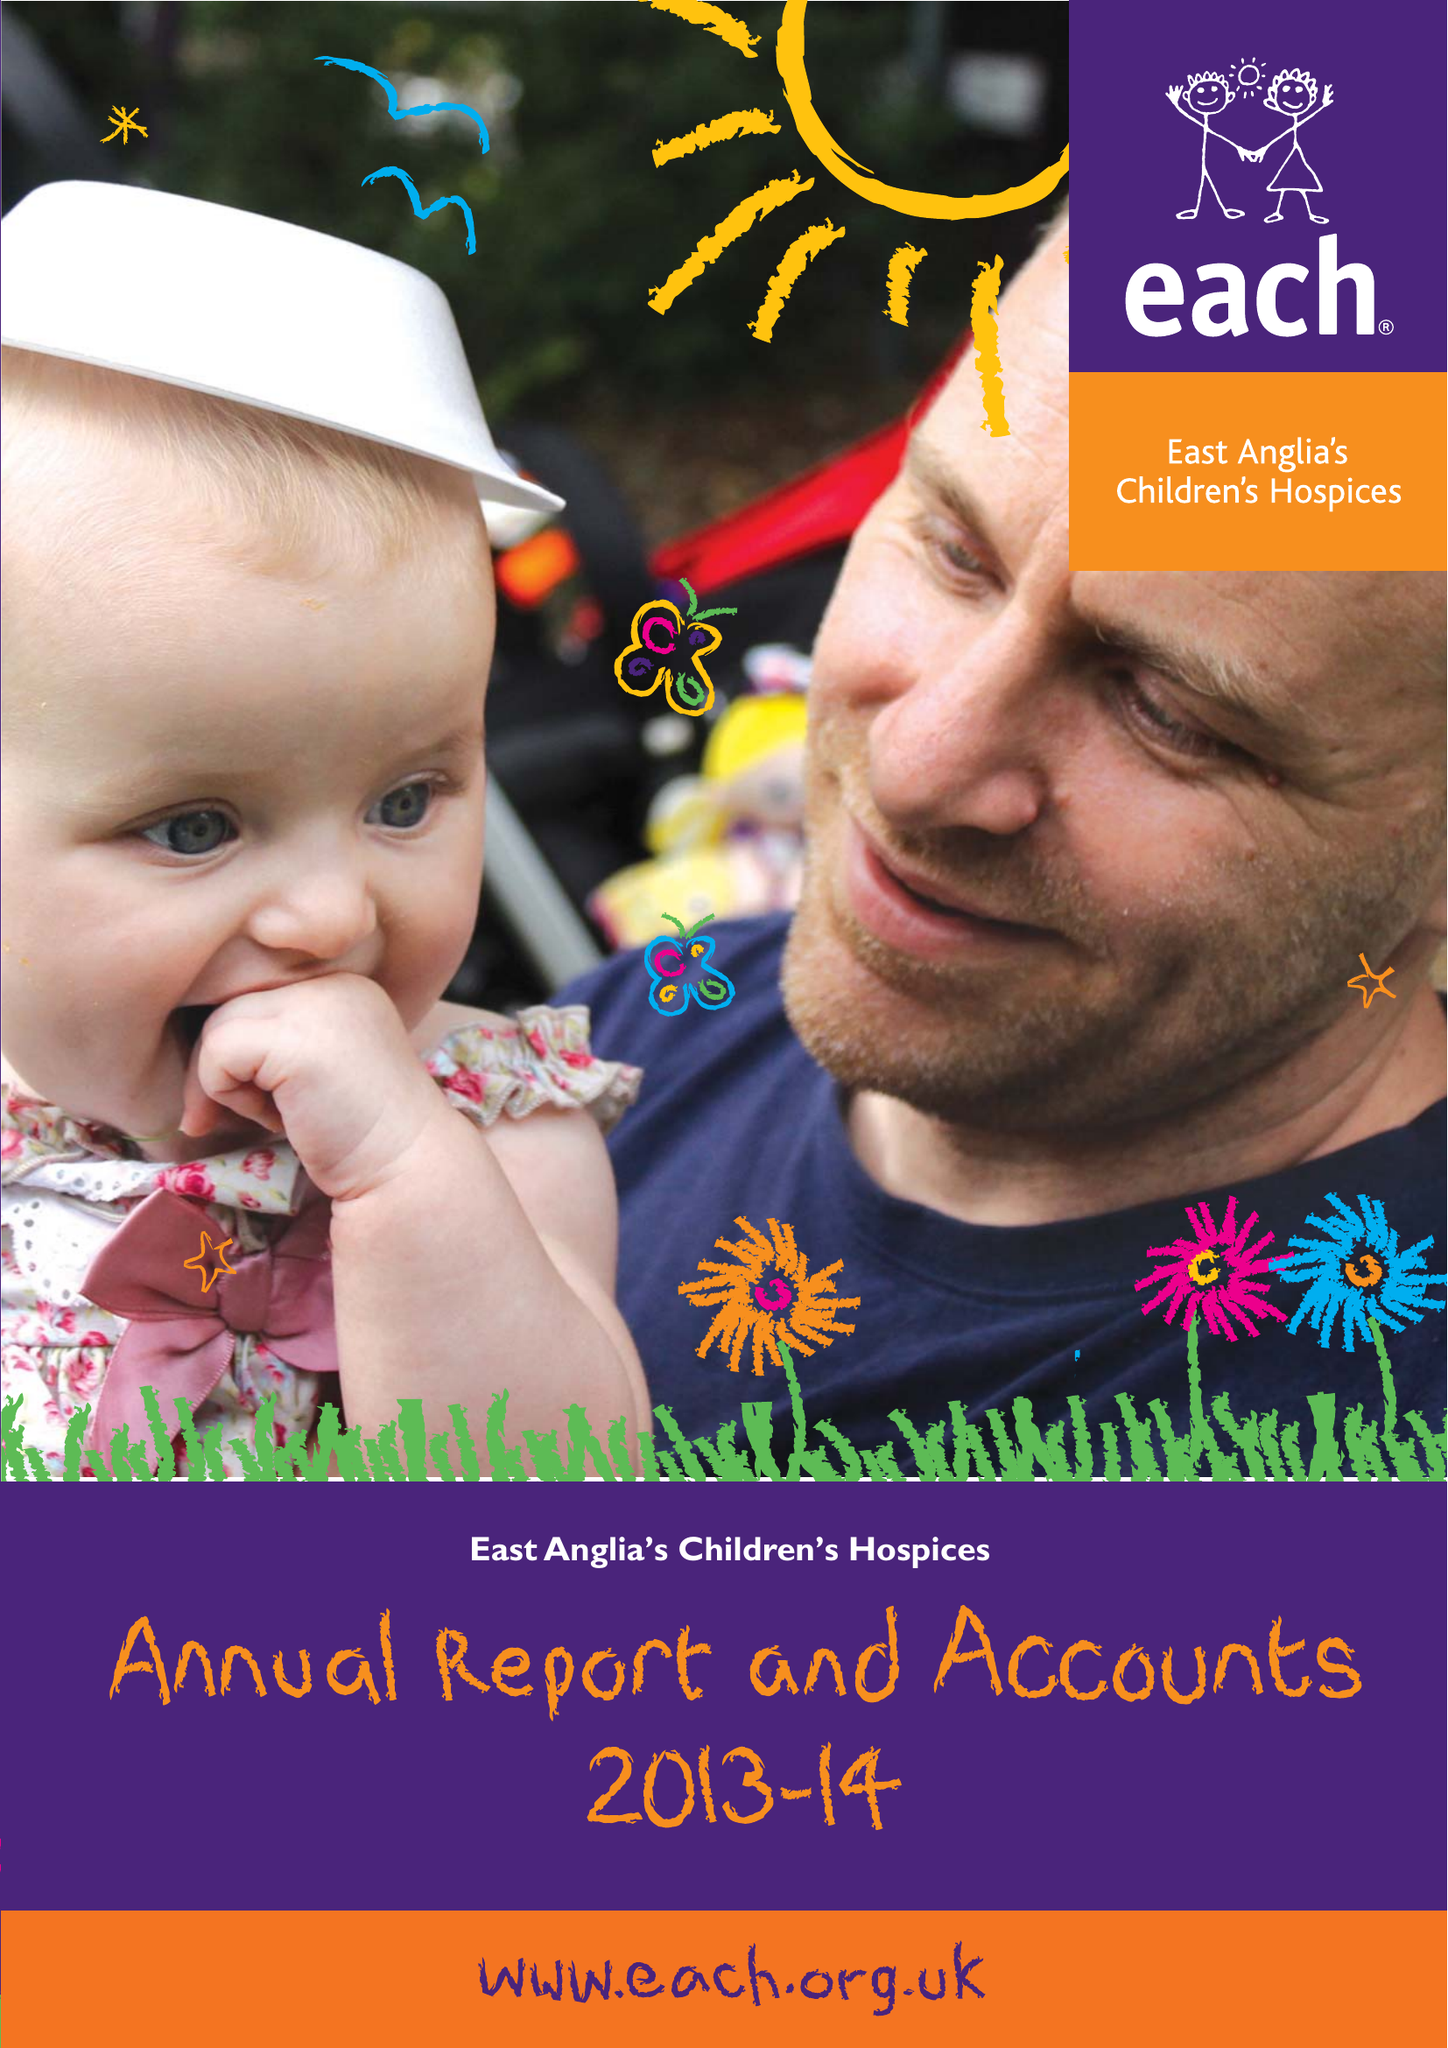What is the value for the spending_annually_in_british_pounds?
Answer the question using a single word or phrase. 10624234.00 